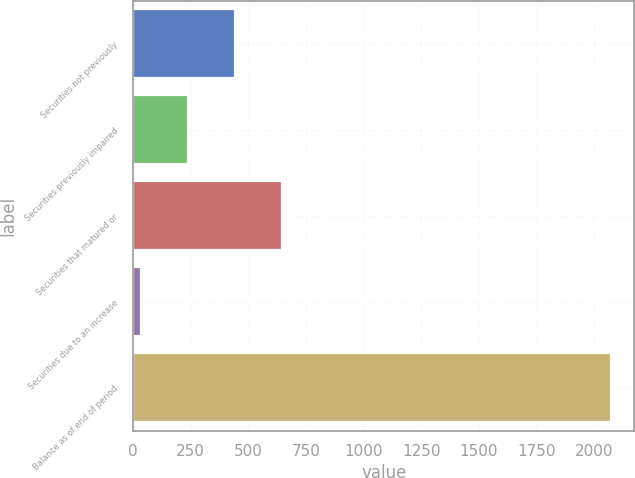Convert chart to OTSL. <chart><loc_0><loc_0><loc_500><loc_500><bar_chart><fcel>Securities not previously<fcel>Securities previously impaired<fcel>Securities that matured or<fcel>Securities due to an increase<fcel>Balance as of end of period<nl><fcel>440<fcel>236<fcel>644<fcel>32<fcel>2072<nl></chart> 